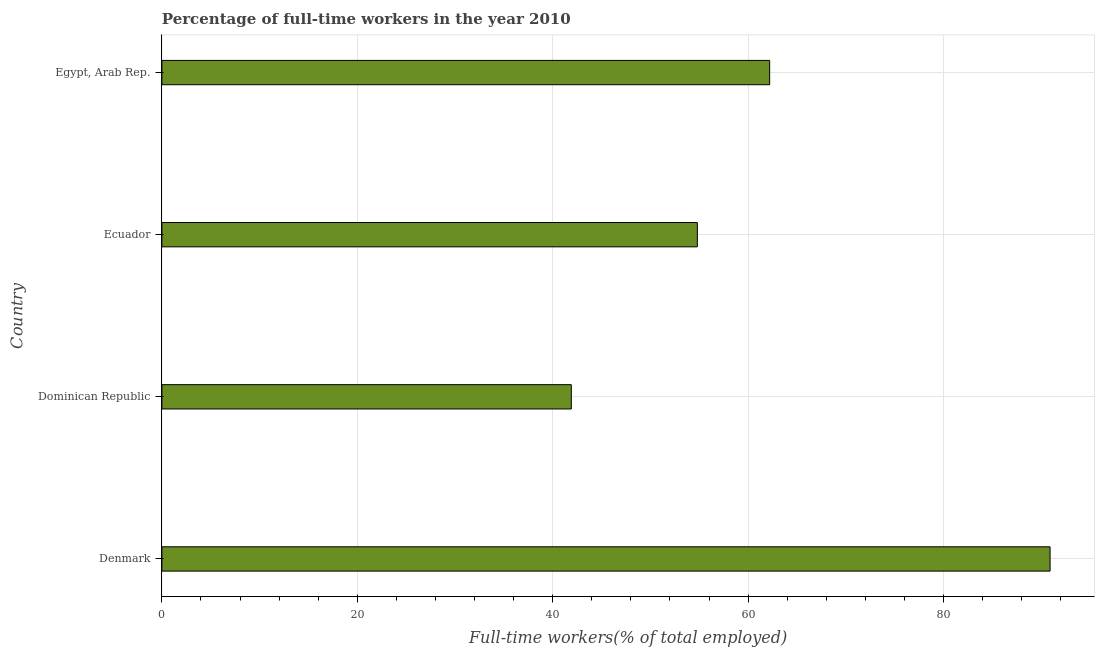Does the graph contain any zero values?
Ensure brevity in your answer.  No. What is the title of the graph?
Ensure brevity in your answer.  Percentage of full-time workers in the year 2010. What is the label or title of the X-axis?
Your answer should be very brief. Full-time workers(% of total employed). What is the percentage of full-time workers in Denmark?
Your answer should be compact. 90.9. Across all countries, what is the maximum percentage of full-time workers?
Make the answer very short. 90.9. Across all countries, what is the minimum percentage of full-time workers?
Make the answer very short. 41.9. In which country was the percentage of full-time workers minimum?
Keep it short and to the point. Dominican Republic. What is the sum of the percentage of full-time workers?
Your answer should be very brief. 249.8. What is the difference between the percentage of full-time workers in Ecuador and Egypt, Arab Rep.?
Offer a terse response. -7.4. What is the average percentage of full-time workers per country?
Your response must be concise. 62.45. What is the median percentage of full-time workers?
Give a very brief answer. 58.5. What is the ratio of the percentage of full-time workers in Denmark to that in Ecuador?
Your response must be concise. 1.66. Is the percentage of full-time workers in Dominican Republic less than that in Ecuador?
Your response must be concise. Yes. Is the difference between the percentage of full-time workers in Denmark and Dominican Republic greater than the difference between any two countries?
Offer a very short reply. Yes. What is the difference between the highest and the second highest percentage of full-time workers?
Your answer should be very brief. 28.7. What is the difference between the highest and the lowest percentage of full-time workers?
Make the answer very short. 49. In how many countries, is the percentage of full-time workers greater than the average percentage of full-time workers taken over all countries?
Your answer should be very brief. 1. How many bars are there?
Your answer should be compact. 4. Are the values on the major ticks of X-axis written in scientific E-notation?
Your answer should be compact. No. What is the Full-time workers(% of total employed) of Denmark?
Provide a short and direct response. 90.9. What is the Full-time workers(% of total employed) in Dominican Republic?
Your answer should be very brief. 41.9. What is the Full-time workers(% of total employed) in Ecuador?
Offer a very short reply. 54.8. What is the Full-time workers(% of total employed) of Egypt, Arab Rep.?
Ensure brevity in your answer.  62.2. What is the difference between the Full-time workers(% of total employed) in Denmark and Dominican Republic?
Provide a succinct answer. 49. What is the difference between the Full-time workers(% of total employed) in Denmark and Ecuador?
Your answer should be compact. 36.1. What is the difference between the Full-time workers(% of total employed) in Denmark and Egypt, Arab Rep.?
Ensure brevity in your answer.  28.7. What is the difference between the Full-time workers(% of total employed) in Dominican Republic and Egypt, Arab Rep.?
Provide a succinct answer. -20.3. What is the ratio of the Full-time workers(% of total employed) in Denmark to that in Dominican Republic?
Give a very brief answer. 2.17. What is the ratio of the Full-time workers(% of total employed) in Denmark to that in Ecuador?
Offer a very short reply. 1.66. What is the ratio of the Full-time workers(% of total employed) in Denmark to that in Egypt, Arab Rep.?
Offer a terse response. 1.46. What is the ratio of the Full-time workers(% of total employed) in Dominican Republic to that in Ecuador?
Make the answer very short. 0.77. What is the ratio of the Full-time workers(% of total employed) in Dominican Republic to that in Egypt, Arab Rep.?
Ensure brevity in your answer.  0.67. What is the ratio of the Full-time workers(% of total employed) in Ecuador to that in Egypt, Arab Rep.?
Ensure brevity in your answer.  0.88. 